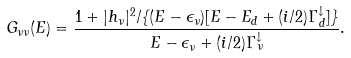Convert formula to latex. <formula><loc_0><loc_0><loc_500><loc_500>G _ { \nu \nu } ( E ) = \frac { 1 + | h _ { \nu } | ^ { 2 } / \{ ( E - \epsilon _ { \nu } ) [ E - E _ { d } + ( i / 2 ) \Gamma ^ { \downarrow } _ { d } ] \} } { E - \epsilon _ { \nu } + ( i / 2 ) \Gamma ^ { \downarrow } _ { \nu } } .</formula> 